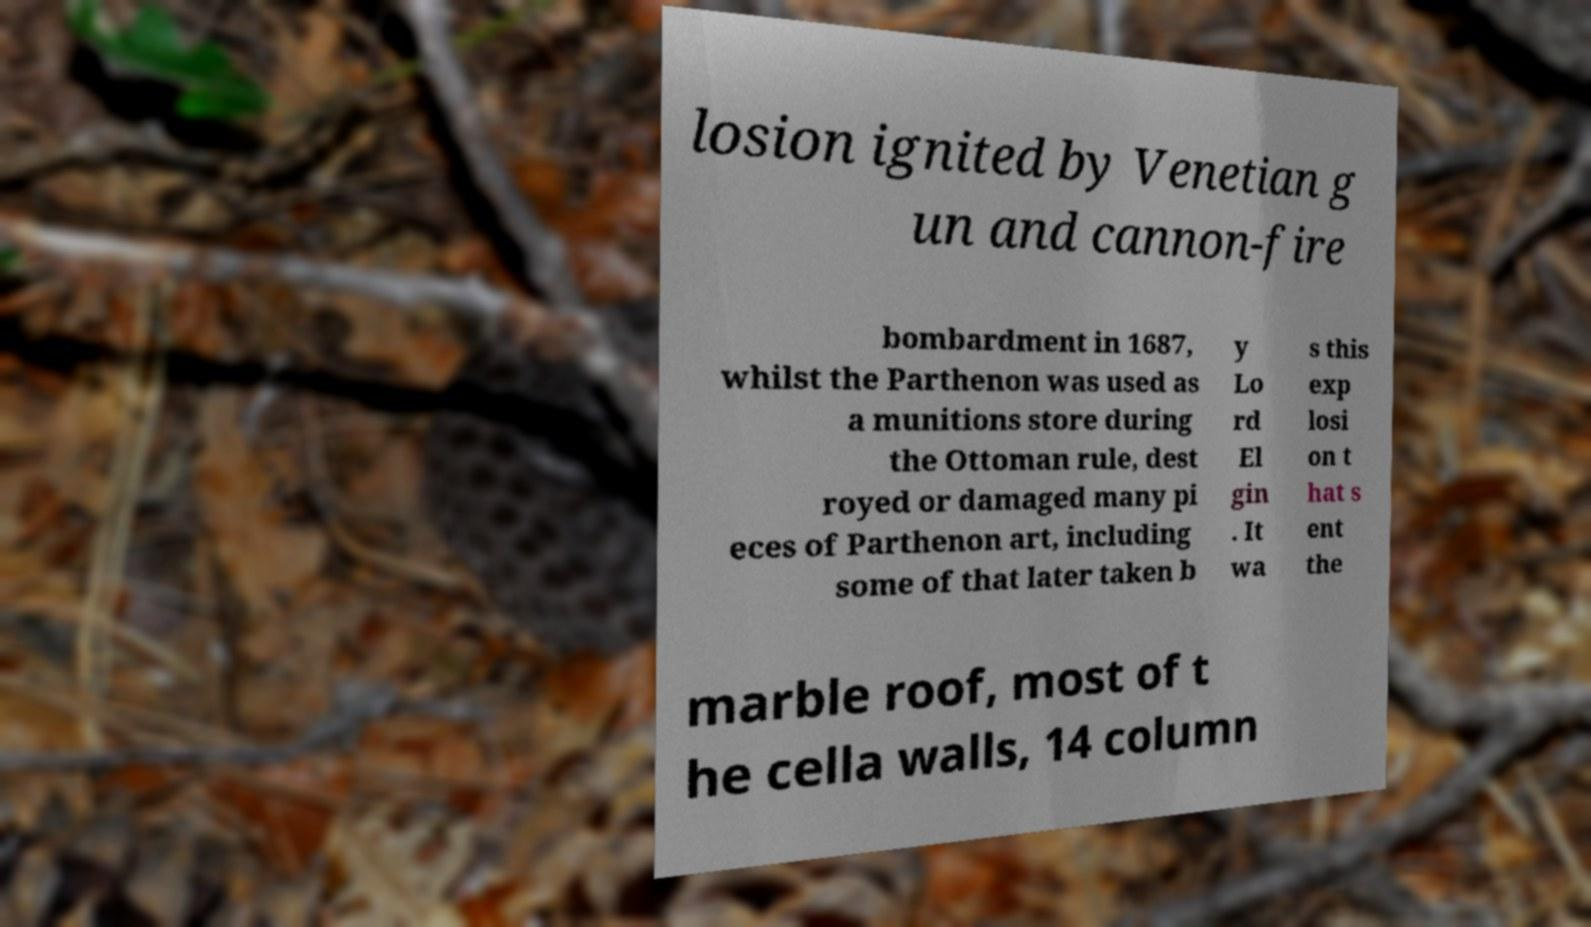Please identify and transcribe the text found in this image. losion ignited by Venetian g un and cannon-fire bombardment in 1687, whilst the Parthenon was used as a munitions store during the Ottoman rule, dest royed or damaged many pi eces of Parthenon art, including some of that later taken b y Lo rd El gin . It wa s this exp losi on t hat s ent the marble roof, most of t he cella walls, 14 column 